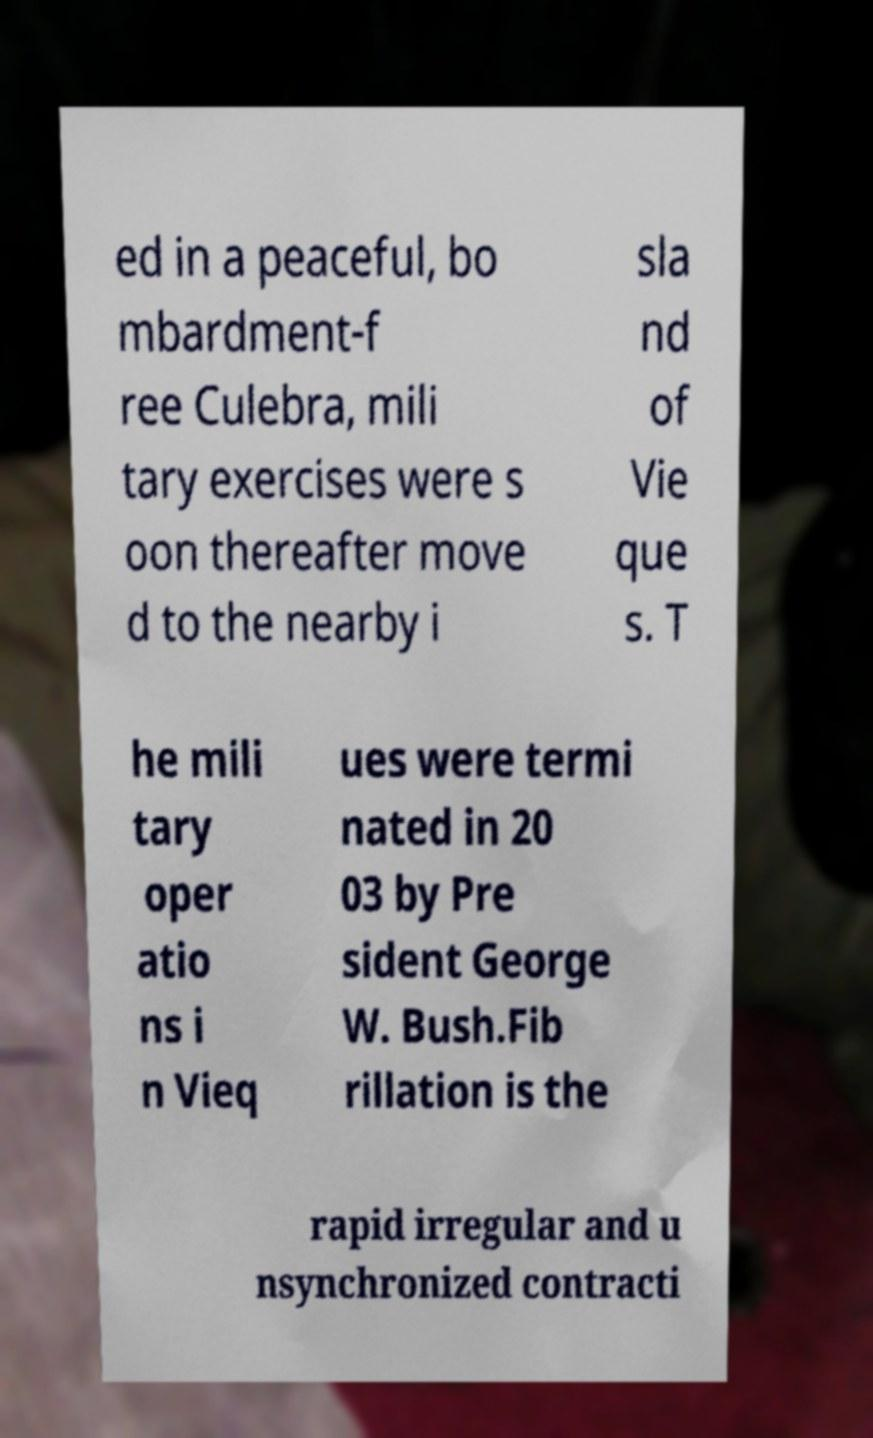There's text embedded in this image that I need extracted. Can you transcribe it verbatim? ed in a peaceful, bo mbardment-f ree Culebra, mili tary exercises were s oon thereafter move d to the nearby i sla nd of Vie que s. T he mili tary oper atio ns i n Vieq ues were termi nated in 20 03 by Pre sident George W. Bush.Fib rillation is the rapid irregular and u nsynchronized contracti 